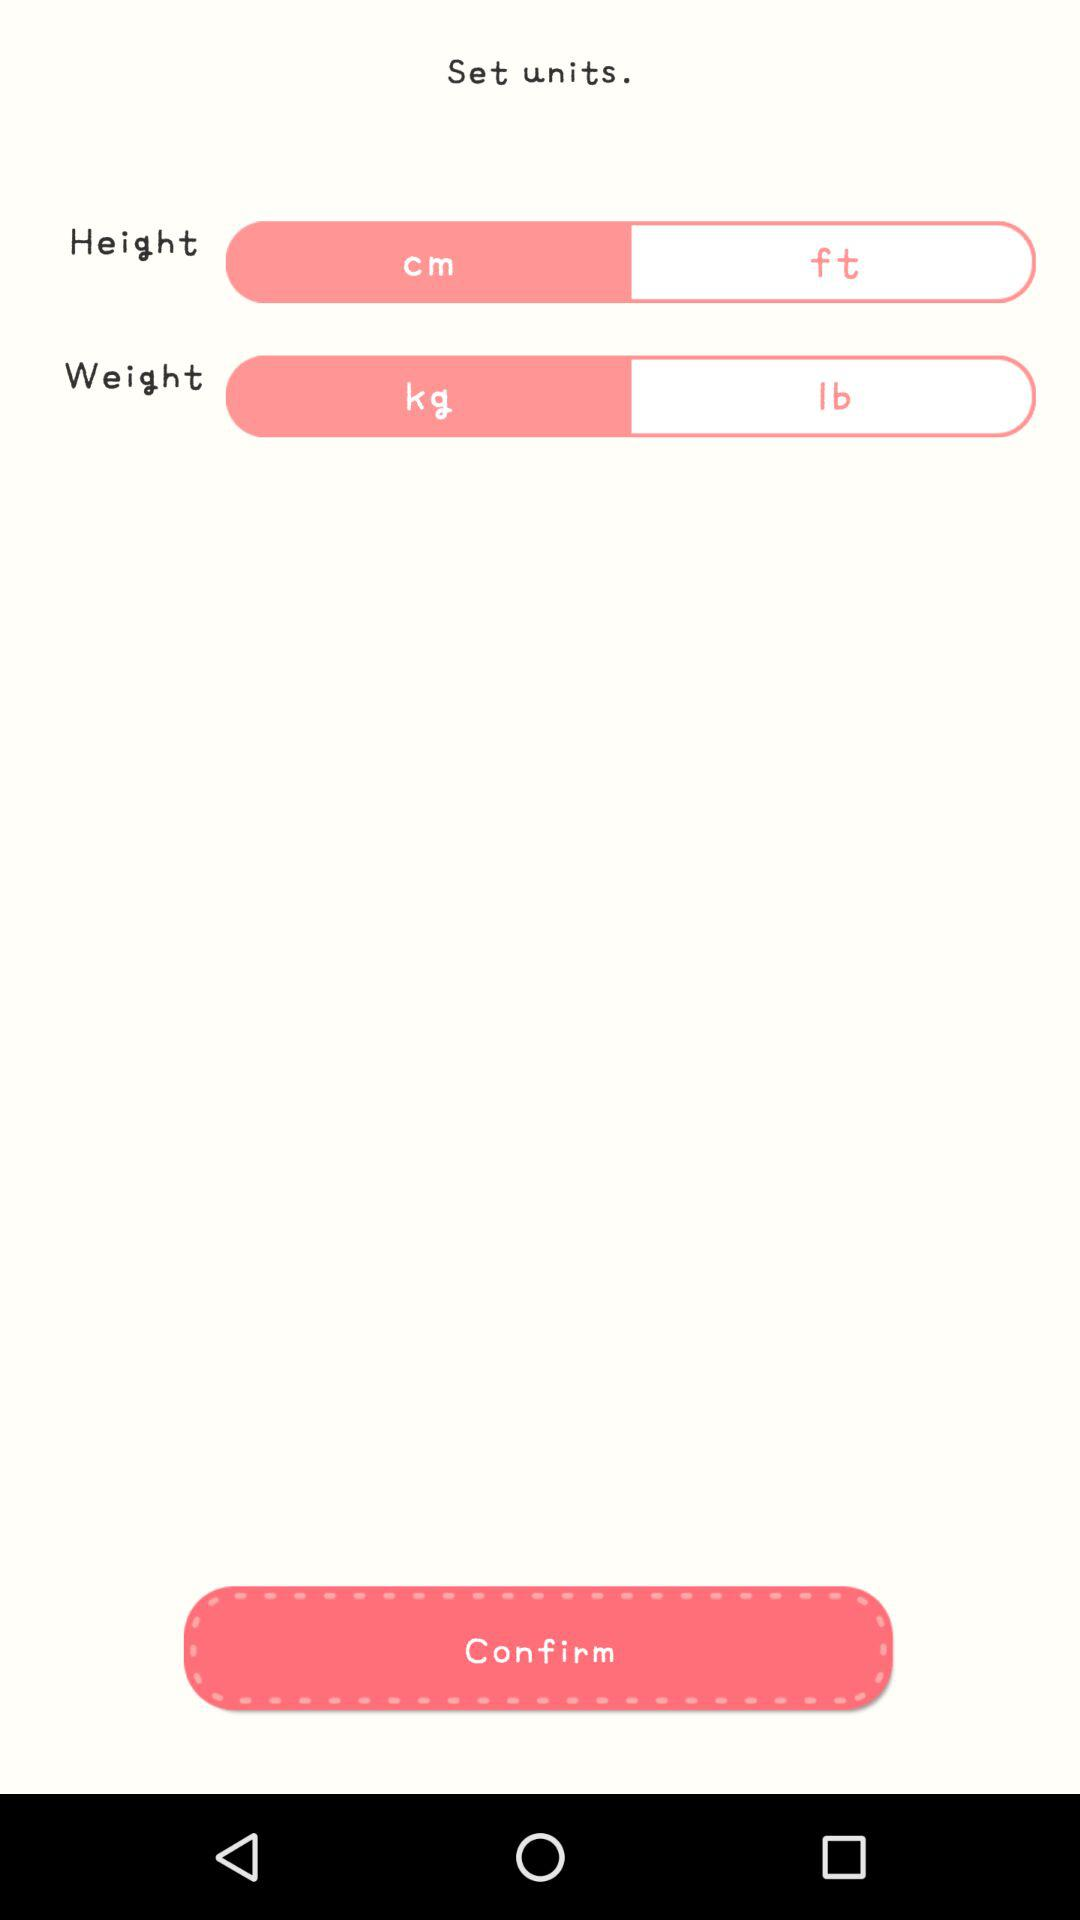What are the units of height? The units of height are centimeters and feet. 